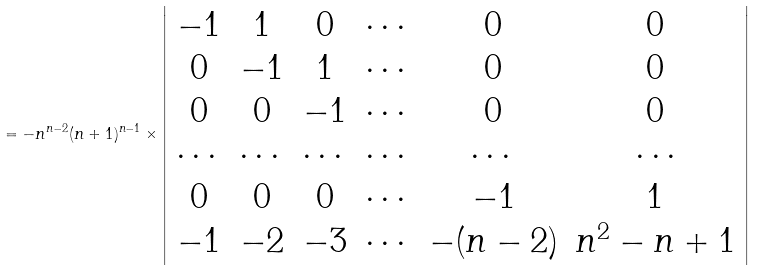<formula> <loc_0><loc_0><loc_500><loc_500>= - n ^ { n - 2 } ( n + 1 ) ^ { n - 1 } \times \left | \begin{array} { c c c c c c } - 1 & 1 & 0 & \cdots & 0 & 0 \\ 0 & - 1 & 1 & \cdots & 0 & 0 \\ 0 & 0 & - 1 & \cdots & 0 & 0 \\ \cdots & \cdots & \cdots & \cdots & \cdots & \cdots \\ 0 & 0 & 0 & \cdots & - 1 & 1 \\ - 1 & - 2 & - 3 & \cdots & - ( n - 2 ) & n ^ { 2 } - n + 1 \\ \end{array} \right |</formula> 